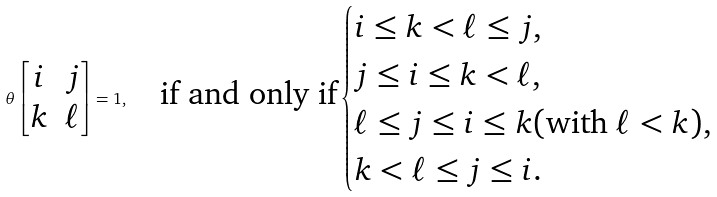<formula> <loc_0><loc_0><loc_500><loc_500>\theta \begin{bmatrix} i & j \\ k & \ell \end{bmatrix} = 1 , \quad \text {if and only if} \begin{cases} i \leq k < \ell \leq j , \\ j \leq i \leq k < \ell , \\ \ell \leq j \leq i \leq k ( \text {with $\ell<k$} ) , \\ k < \ell \leq j \leq i . \end{cases}</formula> 